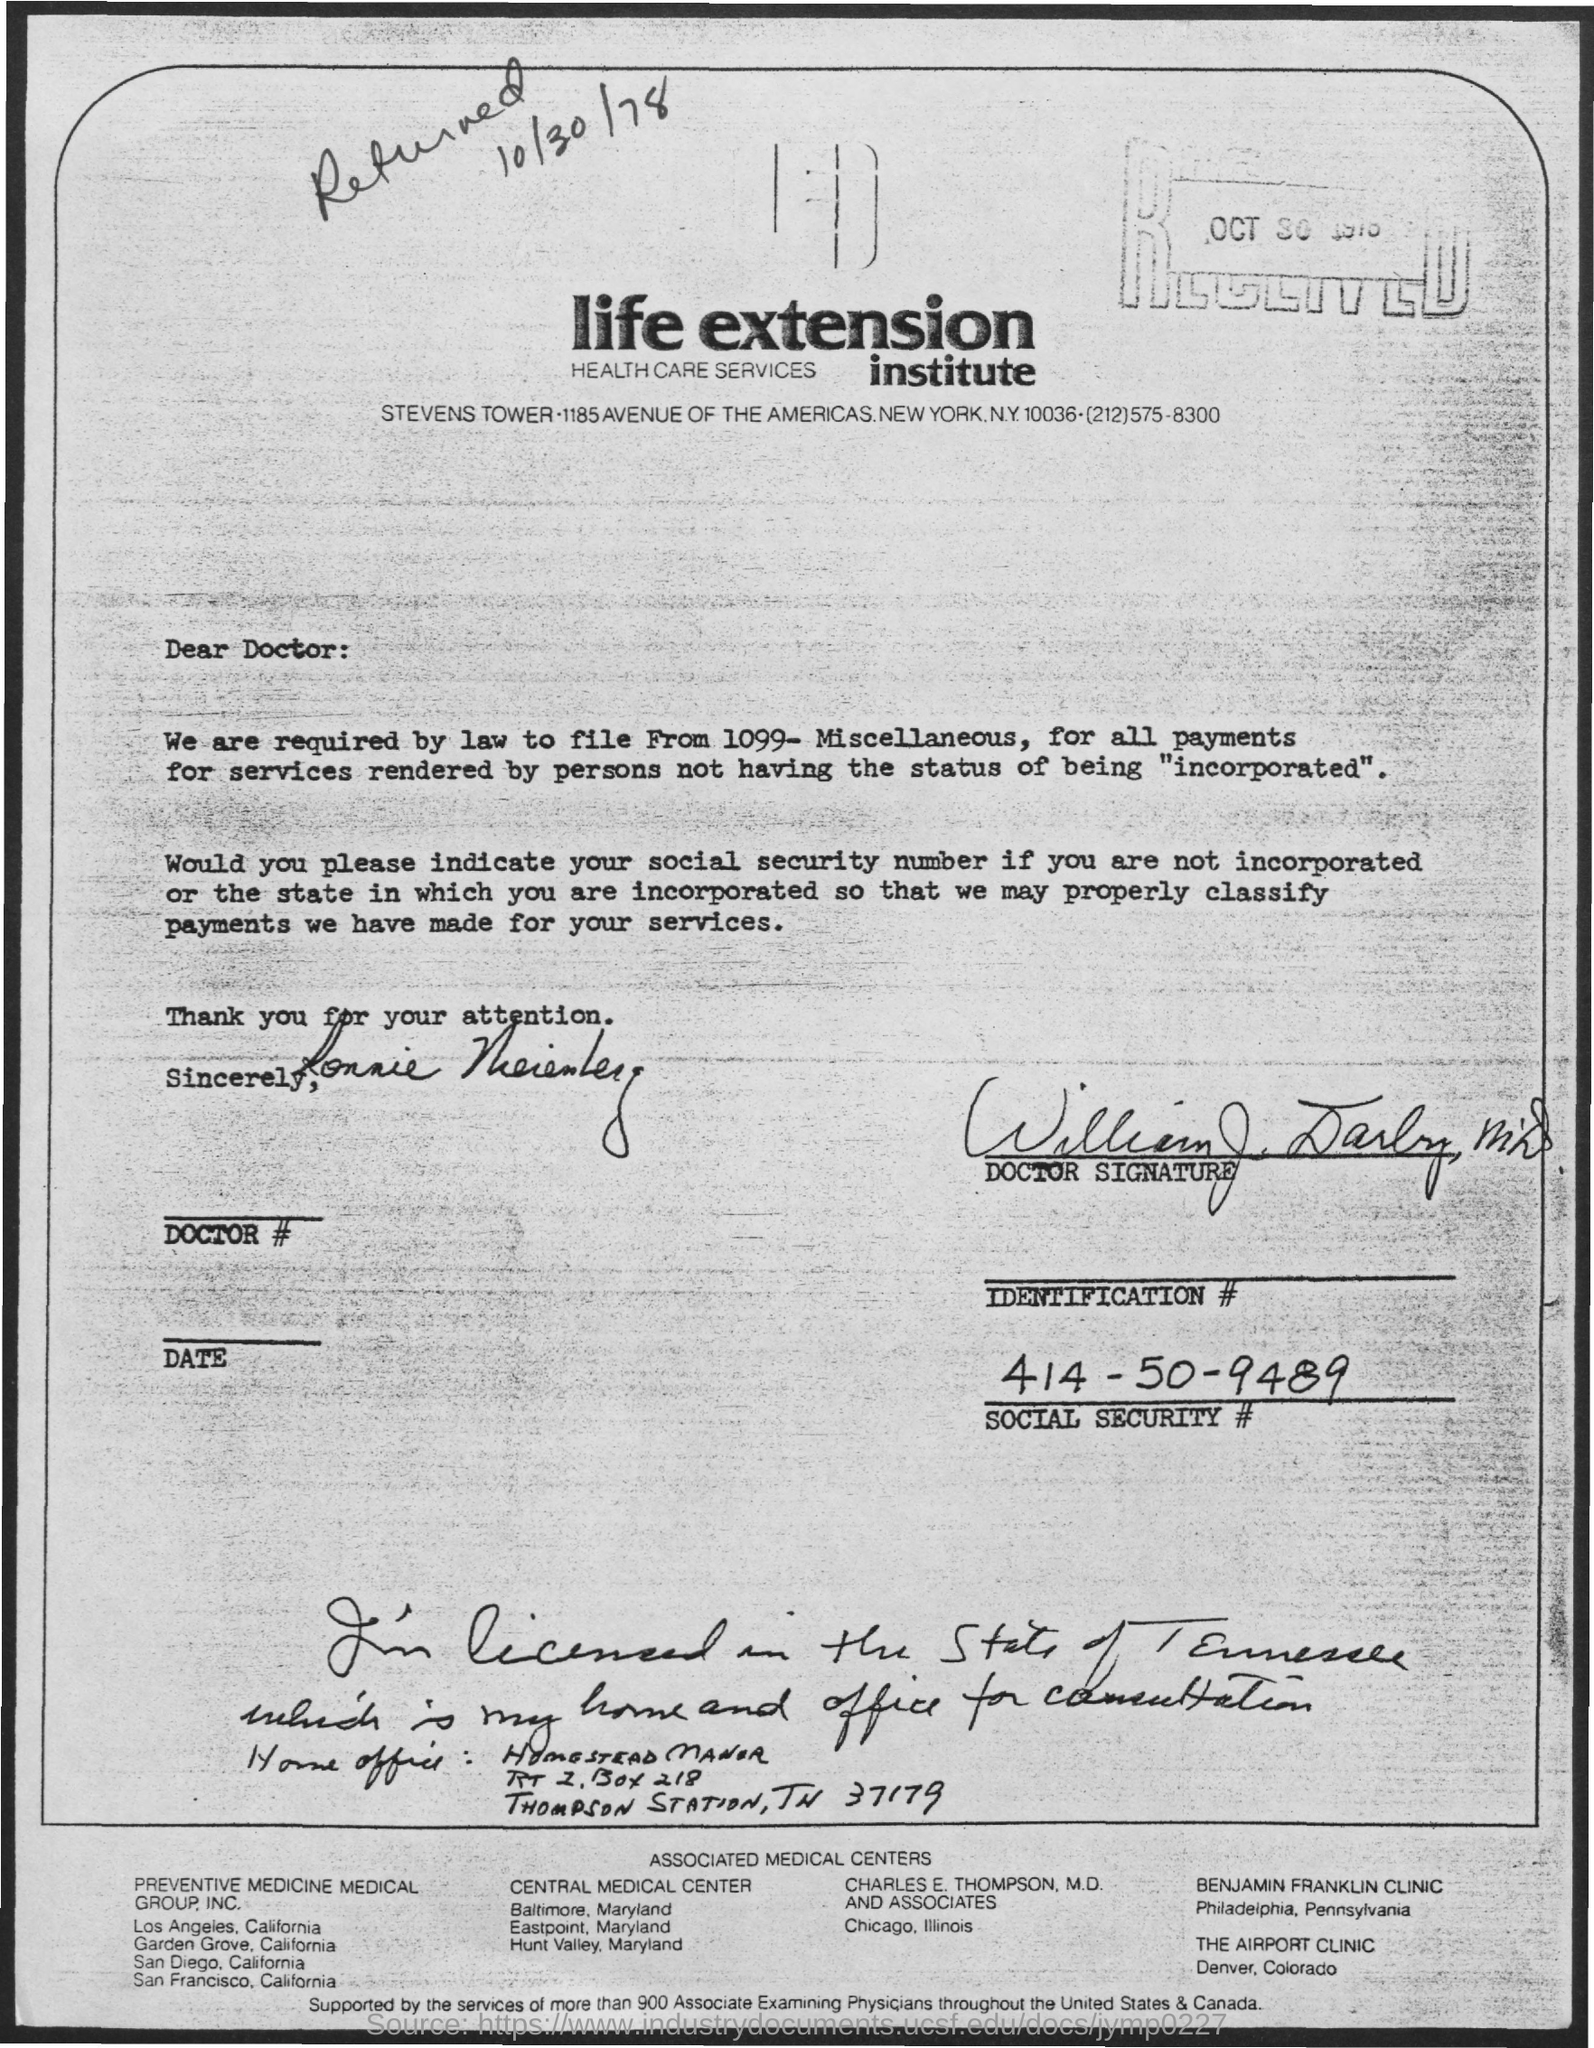Specify some key components in this picture. The Social Security number is 414-50-9489. 